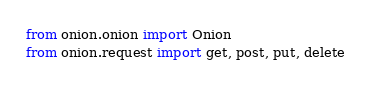<code> <loc_0><loc_0><loc_500><loc_500><_Python_>from onion.onion import Onion
from onion.request import get, post, put, delete
</code> 